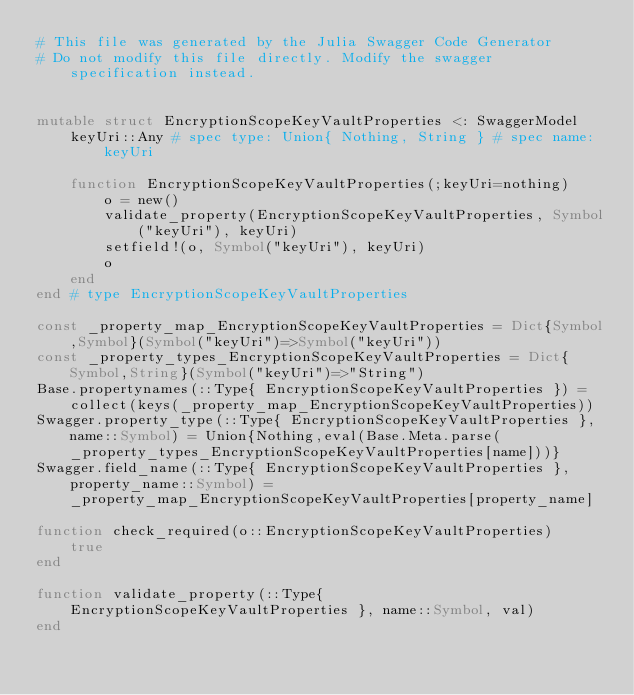Convert code to text. <code><loc_0><loc_0><loc_500><loc_500><_Julia_># This file was generated by the Julia Swagger Code Generator
# Do not modify this file directly. Modify the swagger specification instead.


mutable struct EncryptionScopeKeyVaultProperties <: SwaggerModel
    keyUri::Any # spec type: Union{ Nothing, String } # spec name: keyUri

    function EncryptionScopeKeyVaultProperties(;keyUri=nothing)
        o = new()
        validate_property(EncryptionScopeKeyVaultProperties, Symbol("keyUri"), keyUri)
        setfield!(o, Symbol("keyUri"), keyUri)
        o
    end
end # type EncryptionScopeKeyVaultProperties

const _property_map_EncryptionScopeKeyVaultProperties = Dict{Symbol,Symbol}(Symbol("keyUri")=>Symbol("keyUri"))
const _property_types_EncryptionScopeKeyVaultProperties = Dict{Symbol,String}(Symbol("keyUri")=>"String")
Base.propertynames(::Type{ EncryptionScopeKeyVaultProperties }) = collect(keys(_property_map_EncryptionScopeKeyVaultProperties))
Swagger.property_type(::Type{ EncryptionScopeKeyVaultProperties }, name::Symbol) = Union{Nothing,eval(Base.Meta.parse(_property_types_EncryptionScopeKeyVaultProperties[name]))}
Swagger.field_name(::Type{ EncryptionScopeKeyVaultProperties }, property_name::Symbol) =  _property_map_EncryptionScopeKeyVaultProperties[property_name]

function check_required(o::EncryptionScopeKeyVaultProperties)
    true
end

function validate_property(::Type{ EncryptionScopeKeyVaultProperties }, name::Symbol, val)
end
</code> 